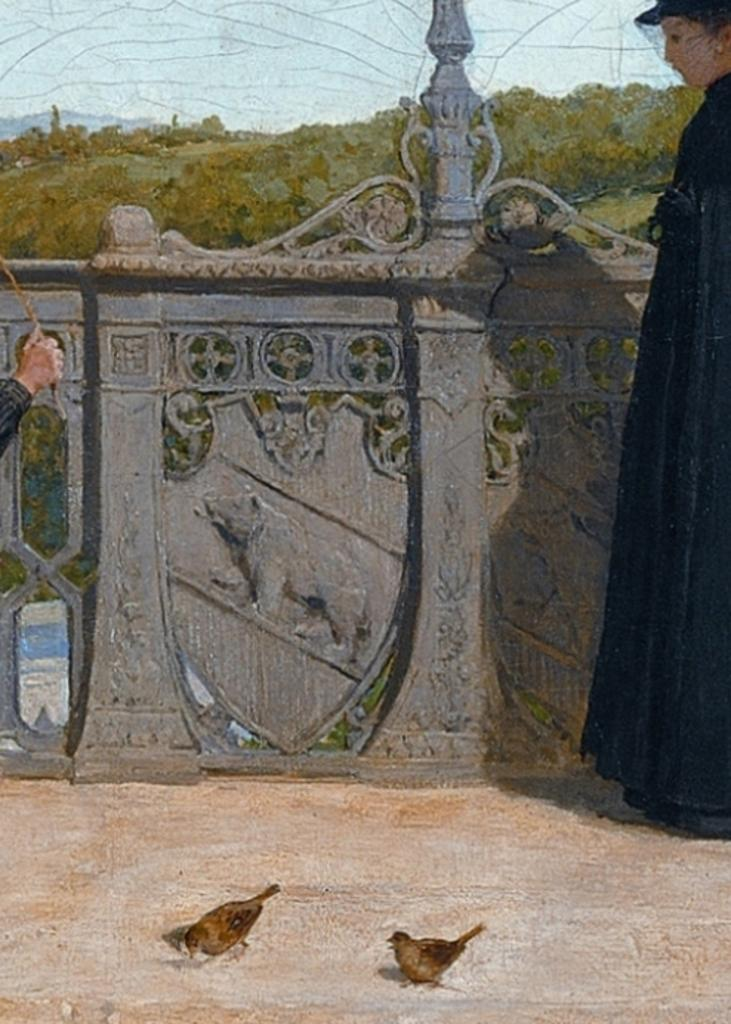How many people are in the image? There are two persons standing in the image. What other living creatures can be seen in the image? Birds are visible in the image. What architectural feature is present in the image? The railing is present in the image. What type of vegetation is visible in the image? Trees are present in the image. What geographical feature can be seen in the background of the image? There is a mountain visible in the background of the image. What part of the natural environment is visible in the background of the image? The sky is visible in the background of the image. What type of bread is being offered to the fearful person in the image? There is no fearful person or bread present in the image. 